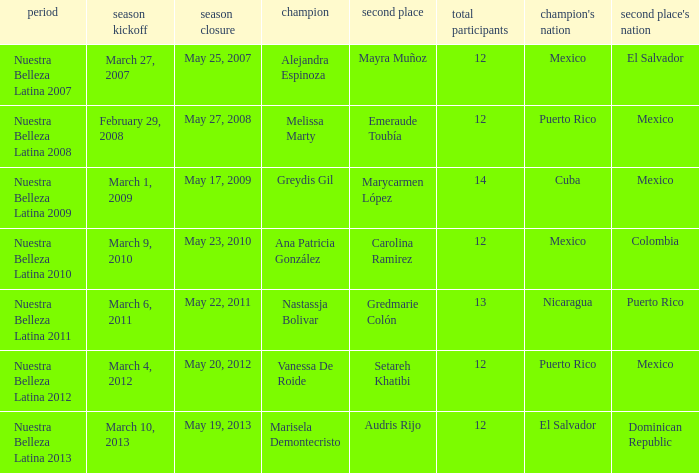What season had mexico as the runner up with melissa marty winning? Nuestra Belleza Latina 2008. 